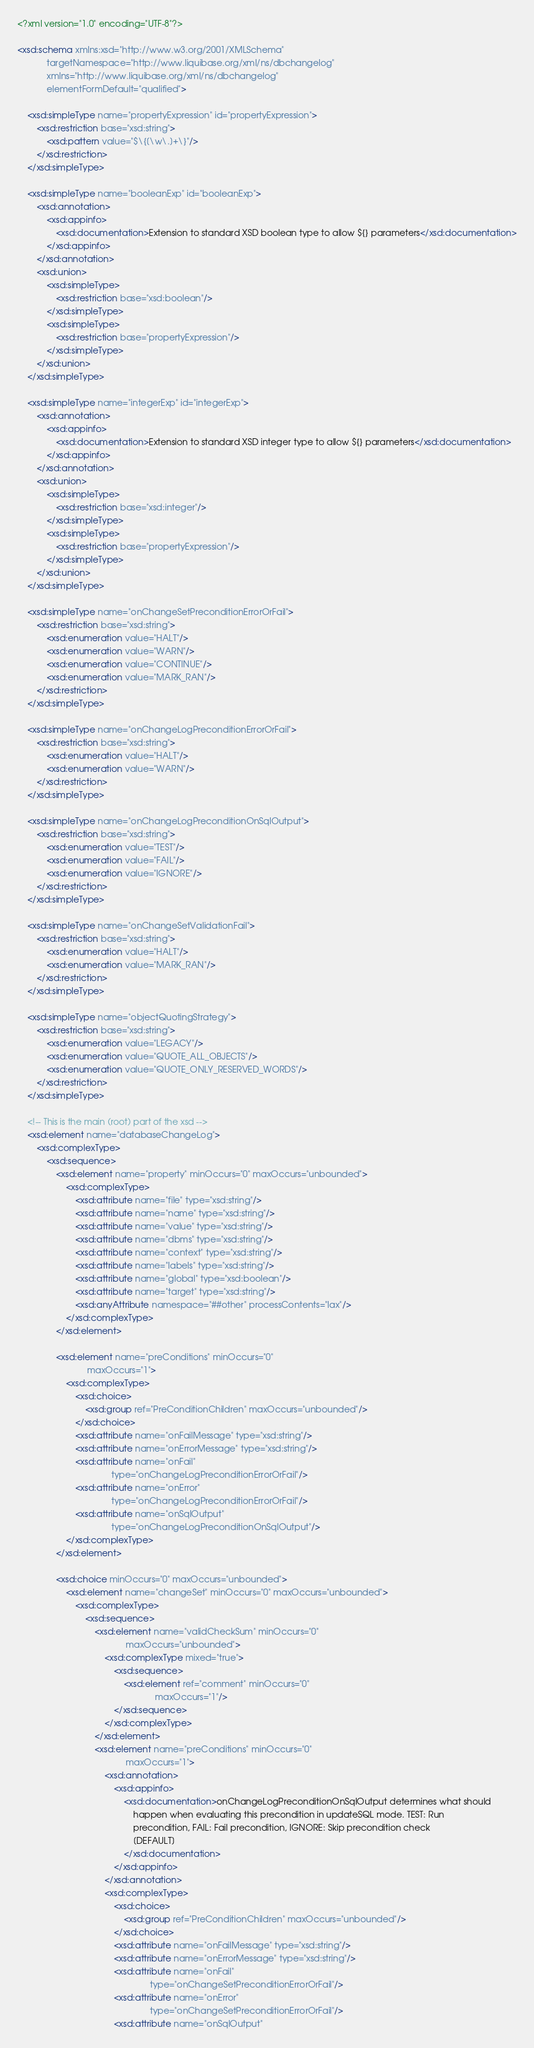<code> <loc_0><loc_0><loc_500><loc_500><_XML_><?xml version="1.0" encoding="UTF-8"?>

<xsd:schema xmlns:xsd="http://www.w3.org/2001/XMLSchema"
            targetNamespace="http://www.liquibase.org/xml/ns/dbchangelog"
            xmlns="http://www.liquibase.org/xml/ns/dbchangelog"
            elementFormDefault="qualified">

    <xsd:simpleType name="propertyExpression" id="propertyExpression">
        <xsd:restriction base="xsd:string">
            <xsd:pattern value="$\{[\w\.]+\}"/>
        </xsd:restriction>
    </xsd:simpleType>

    <xsd:simpleType name="booleanExp" id="booleanExp">
        <xsd:annotation>
            <xsd:appinfo>
                <xsd:documentation>Extension to standard XSD boolean type to allow ${} parameters</xsd:documentation>
            </xsd:appinfo>
        </xsd:annotation>
        <xsd:union>
            <xsd:simpleType>
                <xsd:restriction base="xsd:boolean"/>
            </xsd:simpleType>
            <xsd:simpleType>
                <xsd:restriction base="propertyExpression"/>
            </xsd:simpleType>
        </xsd:union>
    </xsd:simpleType>

    <xsd:simpleType name="integerExp" id="integerExp">
        <xsd:annotation>
            <xsd:appinfo>
                <xsd:documentation>Extension to standard XSD integer type to allow ${} parameters</xsd:documentation>
            </xsd:appinfo>
        </xsd:annotation>
        <xsd:union>
            <xsd:simpleType>
                <xsd:restriction base="xsd:integer"/>
            </xsd:simpleType>
            <xsd:simpleType>
                <xsd:restriction base="propertyExpression"/>
            </xsd:simpleType>
        </xsd:union>
    </xsd:simpleType>

    <xsd:simpleType name="onChangeSetPreconditionErrorOrFail">
        <xsd:restriction base="xsd:string">
            <xsd:enumeration value="HALT"/>
            <xsd:enumeration value="WARN"/>
            <xsd:enumeration value="CONTINUE"/>
            <xsd:enumeration value="MARK_RAN"/>
        </xsd:restriction>
    </xsd:simpleType>

    <xsd:simpleType name="onChangeLogPreconditionErrorOrFail">
        <xsd:restriction base="xsd:string">
            <xsd:enumeration value="HALT"/>
            <xsd:enumeration value="WARN"/>
        </xsd:restriction>
    </xsd:simpleType>

    <xsd:simpleType name="onChangeLogPreconditionOnSqlOutput">
        <xsd:restriction base="xsd:string">
            <xsd:enumeration value="TEST"/>
            <xsd:enumeration value="FAIL"/>
            <xsd:enumeration value="IGNORE"/>
        </xsd:restriction>
    </xsd:simpleType>

    <xsd:simpleType name="onChangeSetValidationFail">
        <xsd:restriction base="xsd:string">
            <xsd:enumeration value="HALT"/>
            <xsd:enumeration value="MARK_RAN"/>
        </xsd:restriction>
    </xsd:simpleType>

    <xsd:simpleType name="objectQuotingStrategy">
        <xsd:restriction base="xsd:string">
            <xsd:enumeration value="LEGACY"/>
            <xsd:enumeration value="QUOTE_ALL_OBJECTS"/>
            <xsd:enumeration value="QUOTE_ONLY_RESERVED_WORDS"/>
        </xsd:restriction>
    </xsd:simpleType>

    <!-- This is the main (root) part of the xsd -->
    <xsd:element name="databaseChangeLog">
        <xsd:complexType>
            <xsd:sequence>
                <xsd:element name="property" minOccurs="0" maxOccurs="unbounded">
                    <xsd:complexType>
                        <xsd:attribute name="file" type="xsd:string"/>
                        <xsd:attribute name="name" type="xsd:string"/>
                        <xsd:attribute name="value" type="xsd:string"/>
                        <xsd:attribute name="dbms" type="xsd:string"/>
                        <xsd:attribute name="context" type="xsd:string"/>
                        <xsd:attribute name="labels" type="xsd:string"/>
                        <xsd:attribute name="global" type="xsd:boolean"/>
                        <xsd:attribute name="target" type="xsd:string"/>
                        <xsd:anyAttribute namespace="##other" processContents="lax"/>
                    </xsd:complexType>
                </xsd:element>

                <xsd:element name="preConditions" minOccurs="0"
                             maxOccurs="1">
                    <xsd:complexType>
                        <xsd:choice>
                            <xsd:group ref="PreConditionChildren" maxOccurs="unbounded"/>
                        </xsd:choice>
                        <xsd:attribute name="onFailMessage" type="xsd:string"/>
                        <xsd:attribute name="onErrorMessage" type="xsd:string"/>
                        <xsd:attribute name="onFail"
                                       type="onChangeLogPreconditionErrorOrFail"/>
                        <xsd:attribute name="onError"
                                       type="onChangeLogPreconditionErrorOrFail"/>
                        <xsd:attribute name="onSqlOutput"
                                       type="onChangeLogPreconditionOnSqlOutput"/>
                    </xsd:complexType>
                </xsd:element>

                <xsd:choice minOccurs="0" maxOccurs="unbounded">
                    <xsd:element name="changeSet" minOccurs="0" maxOccurs="unbounded">
                        <xsd:complexType>
                            <xsd:sequence>
                                <xsd:element name="validCheckSum" minOccurs="0"
                                             maxOccurs="unbounded">
                                    <xsd:complexType mixed="true">
                                        <xsd:sequence>
                                            <xsd:element ref="comment" minOccurs="0"
                                                         maxOccurs="1"/>
                                        </xsd:sequence>
                                    </xsd:complexType>
                                </xsd:element>
                                <xsd:element name="preConditions" minOccurs="0"
                                             maxOccurs="1">
                                    <xsd:annotation>
                                        <xsd:appinfo>
                                            <xsd:documentation>onChangeLogPreconditionOnSqlOutput determines what should
                                                happen when evaluating this precondition in updateSQL mode. TEST: Run
                                                precondition, FAIL: Fail precondition, IGNORE: Skip precondition check
                                                [DEFAULT]
                                            </xsd:documentation>
                                        </xsd:appinfo>
                                    </xsd:annotation>
                                    <xsd:complexType>
                                        <xsd:choice>
                                            <xsd:group ref="PreConditionChildren" maxOccurs="unbounded"/>
                                        </xsd:choice>
                                        <xsd:attribute name="onFailMessage" type="xsd:string"/>
                                        <xsd:attribute name="onErrorMessage" type="xsd:string"/>
                                        <xsd:attribute name="onFail"
                                                       type="onChangeSetPreconditionErrorOrFail"/>
                                        <xsd:attribute name="onError"
                                                       type="onChangeSetPreconditionErrorOrFail"/>
                                        <xsd:attribute name="onSqlOutput"</code> 